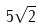Convert formula to latex. <formula><loc_0><loc_0><loc_500><loc_500>5 \sqrt { 2 }</formula> 